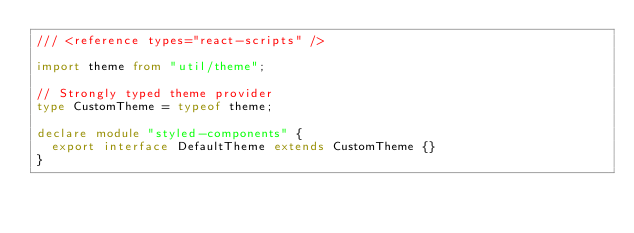Convert code to text. <code><loc_0><loc_0><loc_500><loc_500><_TypeScript_>/// <reference types="react-scripts" />

import theme from "util/theme";

// Strongly typed theme provider
type CustomTheme = typeof theme;

declare module "styled-components" {
  export interface DefaultTheme extends CustomTheme {}
}
</code> 